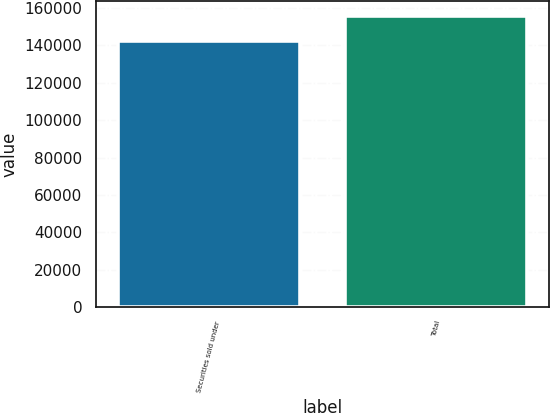Convert chart to OTSL. <chart><loc_0><loc_0><loc_500><loc_500><bar_chart><fcel>Securities sold under<fcel>Total<nl><fcel>142646<fcel>155951<nl></chart> 